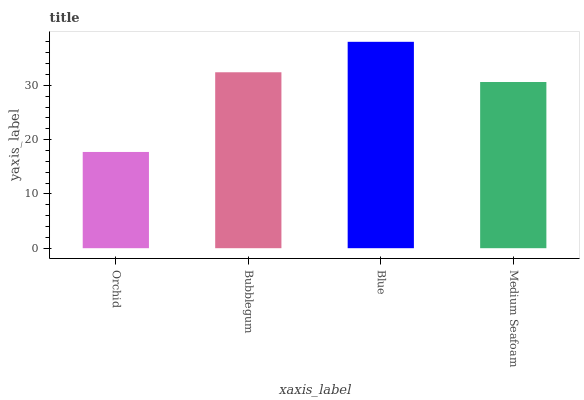Is Orchid the minimum?
Answer yes or no. Yes. Is Blue the maximum?
Answer yes or no. Yes. Is Bubblegum the minimum?
Answer yes or no. No. Is Bubblegum the maximum?
Answer yes or no. No. Is Bubblegum greater than Orchid?
Answer yes or no. Yes. Is Orchid less than Bubblegum?
Answer yes or no. Yes. Is Orchid greater than Bubblegum?
Answer yes or no. No. Is Bubblegum less than Orchid?
Answer yes or no. No. Is Bubblegum the high median?
Answer yes or no. Yes. Is Medium Seafoam the low median?
Answer yes or no. Yes. Is Orchid the high median?
Answer yes or no. No. Is Orchid the low median?
Answer yes or no. No. 